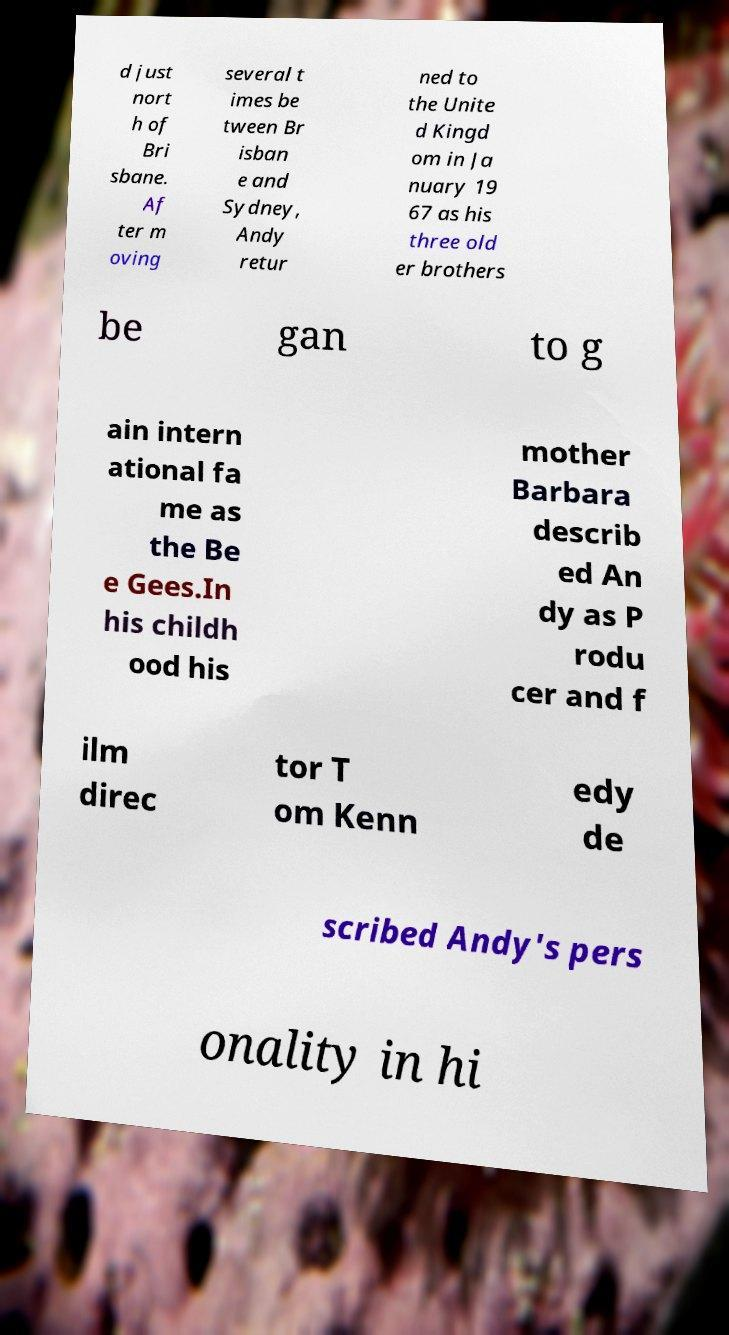I need the written content from this picture converted into text. Can you do that? d just nort h of Bri sbane. Af ter m oving several t imes be tween Br isban e and Sydney, Andy retur ned to the Unite d Kingd om in Ja nuary 19 67 as his three old er brothers be gan to g ain intern ational fa me as the Be e Gees.In his childh ood his mother Barbara describ ed An dy as P rodu cer and f ilm direc tor T om Kenn edy de scribed Andy's pers onality in hi 